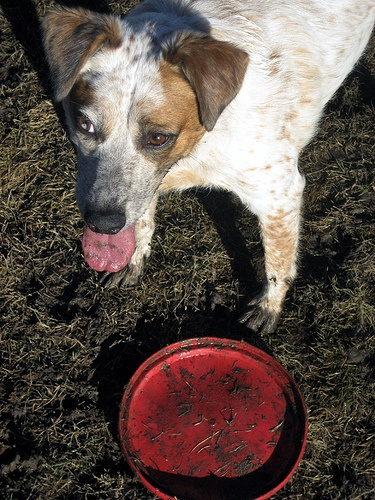Describe the objects in this image and their specific colors. I can see dog in black, lightgray, gray, and darkgray tones and frisbee in black, maroon, brown, and salmon tones in this image. 